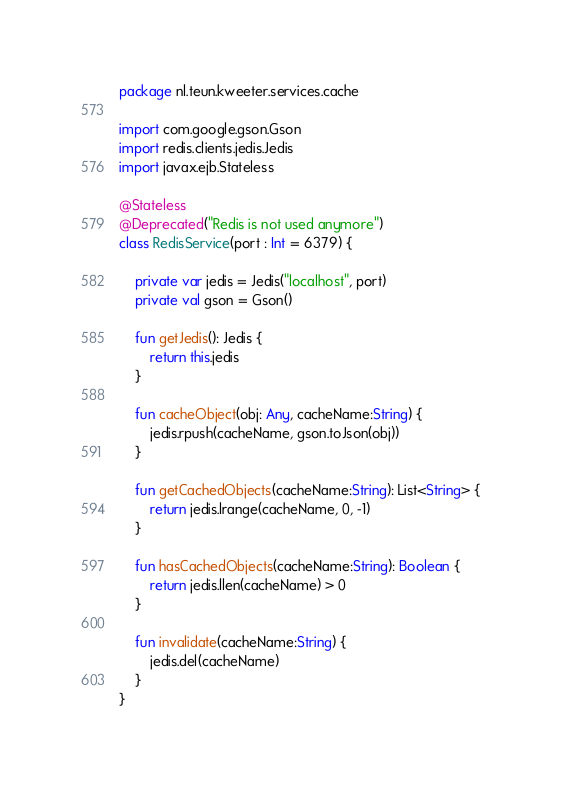<code> <loc_0><loc_0><loc_500><loc_500><_Kotlin_>package nl.teun.kweeter.services.cache

import com.google.gson.Gson
import redis.clients.jedis.Jedis
import javax.ejb.Stateless

@Stateless
@Deprecated("Redis is not used anymore")
class RedisService(port : Int = 6379) {

    private var jedis = Jedis("localhost", port)
    private val gson = Gson()

    fun getJedis(): Jedis {
        return this.jedis
    }

    fun cacheObject(obj: Any, cacheName:String) {
        jedis.rpush(cacheName, gson.toJson(obj))
    }

    fun getCachedObjects(cacheName:String): List<String> {
        return jedis.lrange(cacheName, 0, -1)
    }

    fun hasCachedObjects(cacheName:String): Boolean {
        return jedis.llen(cacheName) > 0
    }

    fun invalidate(cacheName:String) {
        jedis.del(cacheName)
    }
}</code> 